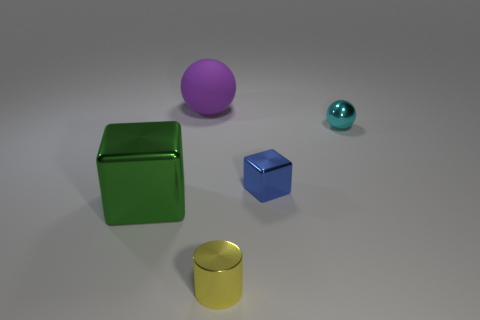Subtract 1 cubes. How many cubes are left? 1 Add 2 tiny cyan shiny objects. How many objects exist? 7 Subtract all cylinders. How many objects are left? 4 Add 2 green blocks. How many green blocks are left? 3 Add 5 small cyan metallic balls. How many small cyan metallic balls exist? 6 Subtract 0 cyan cylinders. How many objects are left? 5 Subtract all green spheres. Subtract all purple blocks. How many spheres are left? 2 Subtract all tiny yellow metallic things. Subtract all large green blocks. How many objects are left? 3 